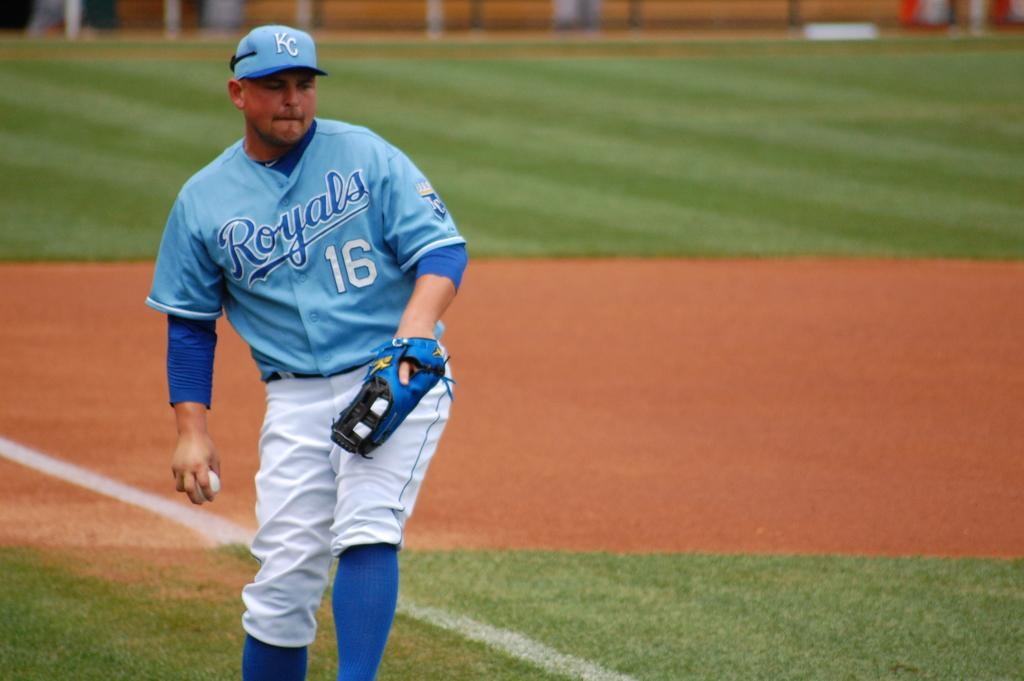<image>
Write a terse but informative summary of the picture. A player for the Royals baseball team throwing a baseball. 